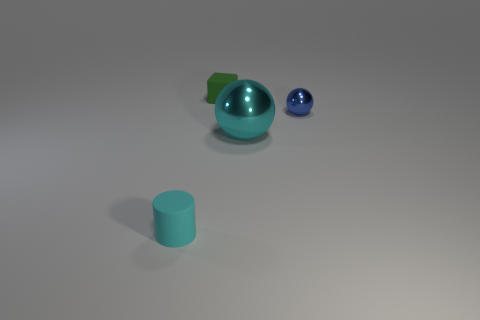Add 1 tiny cyan rubber things. How many objects exist? 5 Subtract 1 cylinders. How many cylinders are left? 0 Subtract all tiny blue metallic blocks. Subtract all big things. How many objects are left? 3 Add 1 tiny matte cylinders. How many tiny matte cylinders are left? 2 Add 3 tiny matte cylinders. How many tiny matte cylinders exist? 4 Subtract 1 cyan cylinders. How many objects are left? 3 Subtract all yellow cylinders. Subtract all purple spheres. How many cylinders are left? 1 